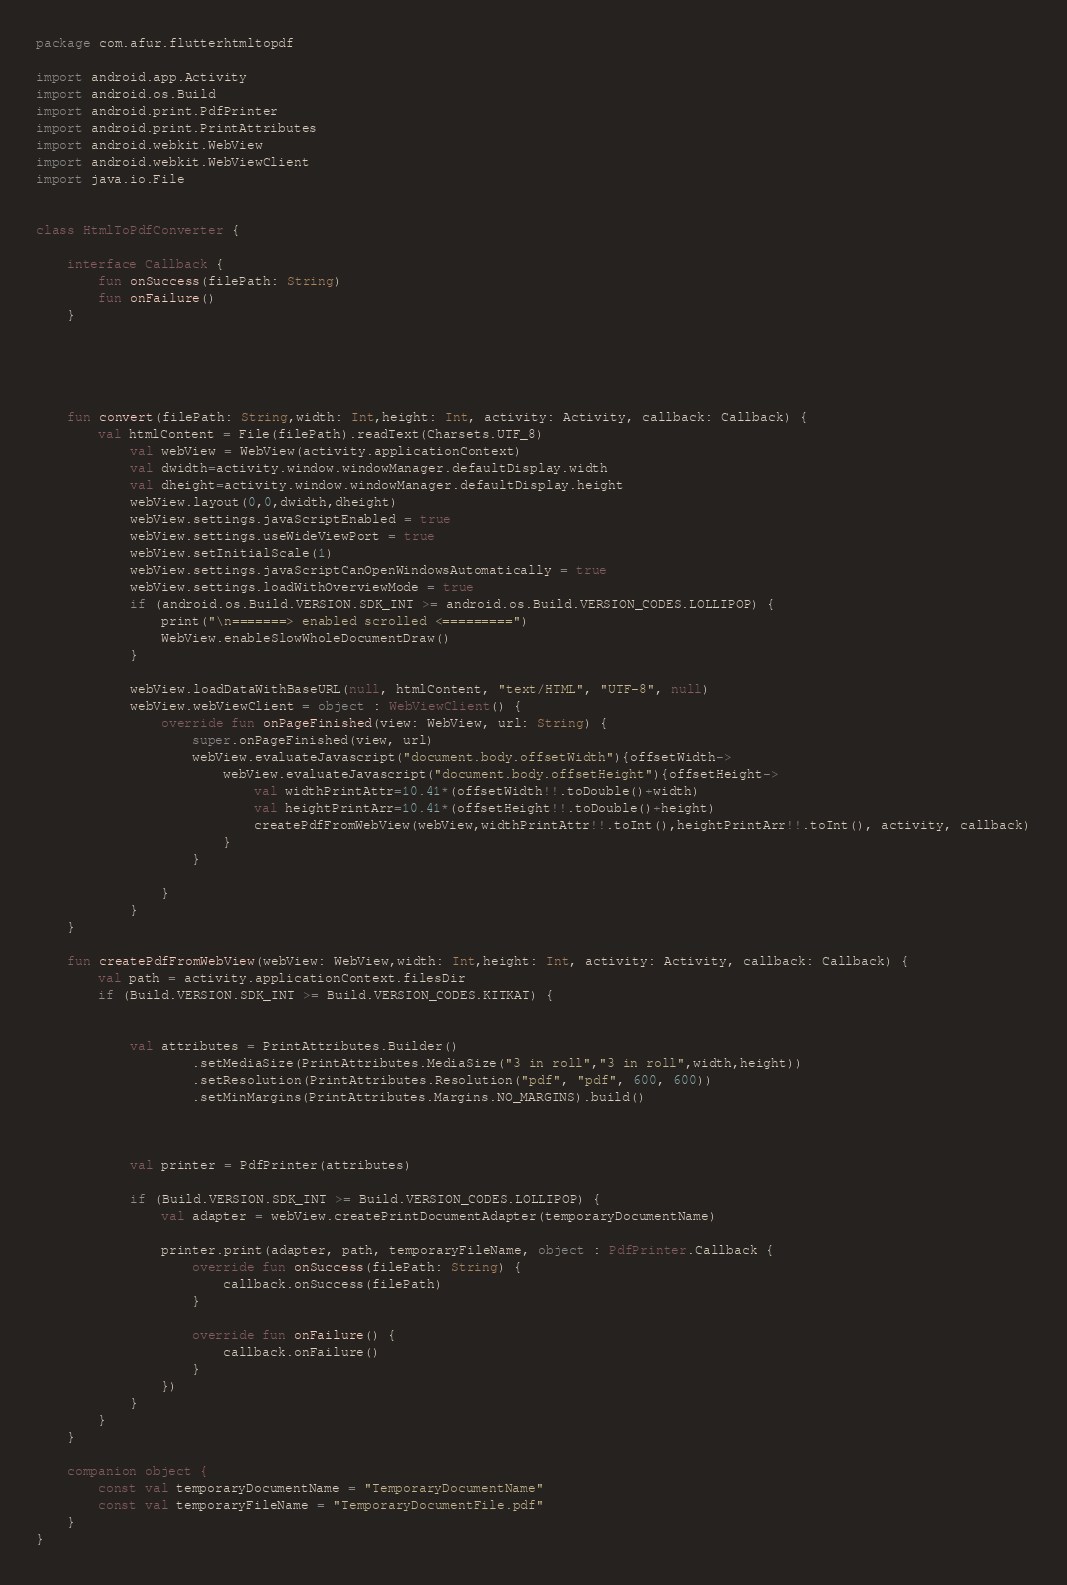<code> <loc_0><loc_0><loc_500><loc_500><_Kotlin_>package com.afur.flutterhtmltopdf

import android.app.Activity
import android.os.Build
import android.print.PdfPrinter
import android.print.PrintAttributes
import android.webkit.WebView
import android.webkit.WebViewClient
import java.io.File


class HtmlToPdfConverter {

    interface Callback {
        fun onSuccess(filePath: String)
        fun onFailure()
    }
	
	
	


    fun convert(filePath: String,width: Int,height: Int, activity: Activity, callback: Callback) {
		val htmlContent = File(filePath).readText(Charsets.UTF_8)
			val webView = WebView(activity.applicationContext)
			val dwidth=activity.window.windowManager.defaultDisplay.width
			val dheight=activity.window.windowManager.defaultDisplay.height
			webView.layout(0,0,dwidth,dheight)
			webView.settings.javaScriptEnabled = true
			webView.settings.useWideViewPort = true
			webView.setInitialScale(1)
			webView.settings.javaScriptCanOpenWindowsAutomatically = true
			webView.settings.loadWithOverviewMode = true
			if (android.os.Build.VERSION.SDK_INT >= android.os.Build.VERSION_CODES.LOLLIPOP) {
				print("\n=======> enabled scrolled <=========")
				WebView.enableSlowWholeDocumentDraw()
			}

			webView.loadDataWithBaseURL(null, htmlContent, "text/HTML", "UTF-8", null)
			webView.webViewClient = object : WebViewClient() {
				override fun onPageFinished(view: WebView, url: String) {
					super.onPageFinished(view, url)
					webView.evaluateJavascript("document.body.offsetWidth"){offsetWidth->
						webView.evaluateJavascript("document.body.offsetHeight"){offsetHeight->
							val widthPrintAttr=10.41*(offsetWidth!!.toDouble()+width)
							val heightPrintArr=10.41*(offsetHeight!!.toDouble()+height)
							createPdfFromWebView(webView,widthPrintAttr!!.toInt(),heightPrintArr!!.toInt(), activity, callback)
						}
					}

				}
			}
    }

    fun createPdfFromWebView(webView: WebView,width: Int,height: Int, activity: Activity, callback: Callback) {
        val path = activity.applicationContext.filesDir
        if (Build.VERSION.SDK_INT >= Build.VERSION_CODES.KITKAT) {
		
			
            val attributes = PrintAttributes.Builder()
                    .setMediaSize(PrintAttributes.MediaSize("3 in roll","3 in roll",width,height))
                    .setResolution(PrintAttributes.Resolution("pdf", "pdf", 600, 600))
                    .setMinMargins(PrintAttributes.Margins.NO_MARGINS).build()

            

            val printer = PdfPrinter(attributes)

            if (Build.VERSION.SDK_INT >= Build.VERSION_CODES.LOLLIPOP) {
                val adapter = webView.createPrintDocumentAdapter(temporaryDocumentName)

                printer.print(adapter, path, temporaryFileName, object : PdfPrinter.Callback {
                    override fun onSuccess(filePath: String) {
                        callback.onSuccess(filePath)
                    }

                    override fun onFailure() {
                        callback.onFailure()
                    }
                })
            }
        }
    }

    companion object {
        const val temporaryDocumentName = "TemporaryDocumentName"
        const val temporaryFileName = "TemporaryDocumentFile.pdf"
    }
}</code> 